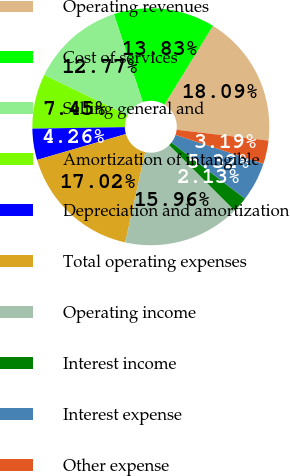Convert chart to OTSL. <chart><loc_0><loc_0><loc_500><loc_500><pie_chart><fcel>Operating revenues<fcel>Cost of services<fcel>Selling general and<fcel>Amortization of intangible<fcel>Depreciation and amortization<fcel>Total operating expenses<fcel>Operating income<fcel>Interest income<fcel>Interest expense<fcel>Other expense<nl><fcel>18.09%<fcel>13.83%<fcel>12.77%<fcel>7.45%<fcel>4.26%<fcel>17.02%<fcel>15.96%<fcel>2.13%<fcel>5.32%<fcel>3.19%<nl></chart> 